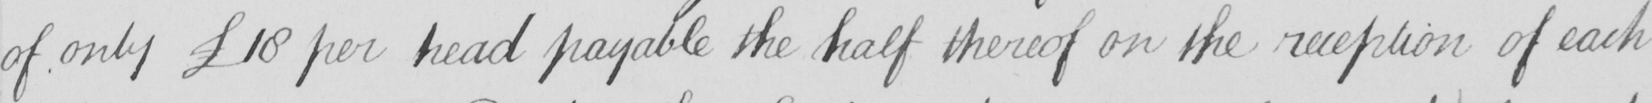Please transcribe the handwritten text in this image. of only  £18 per head payable the half thereof on the reception of each 